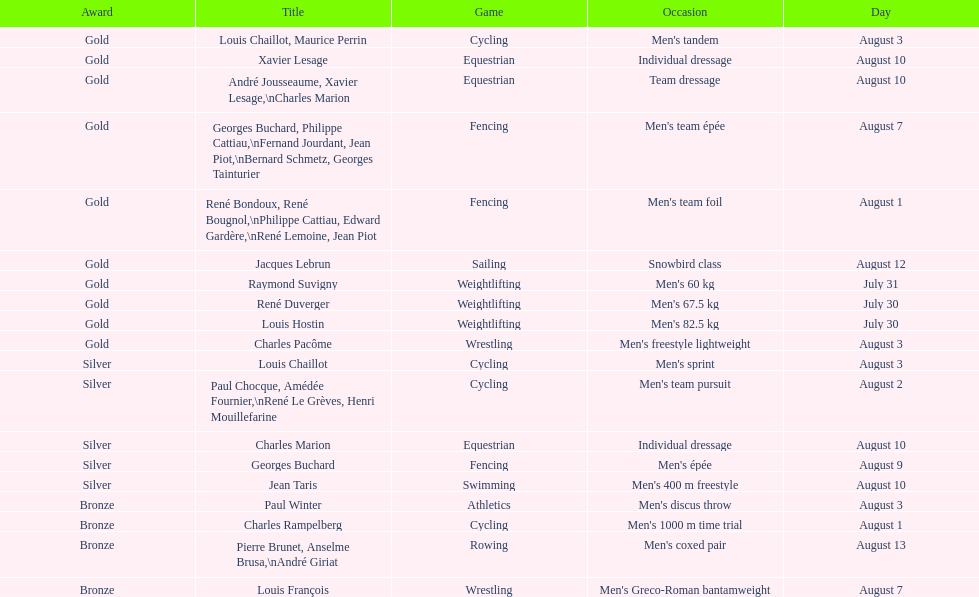Did gold medals surpass silver medals in quantity? Yes. 